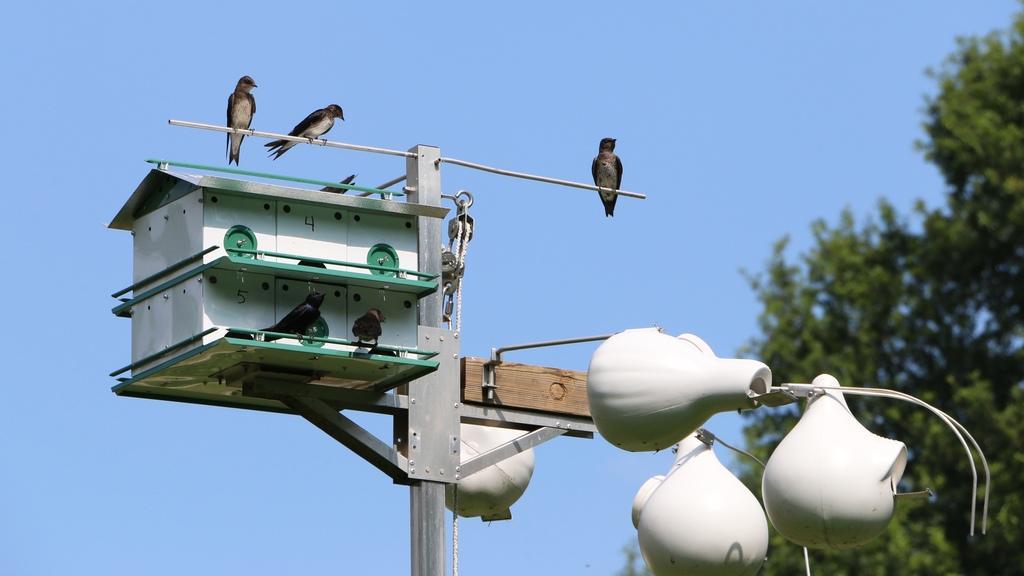Please provide a concise description of this image. In this image I can see the light pole and the bird house to the pole. I can see few birds on the pole. These birds are in white and black color. In the background I can see trees and the sky. 